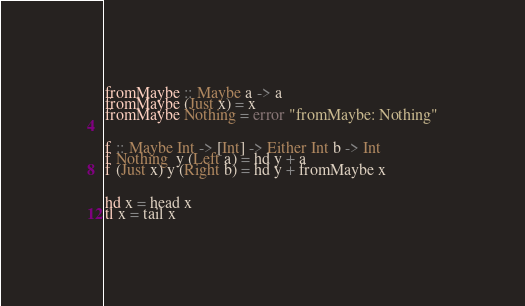Convert code to text. <code><loc_0><loc_0><loc_500><loc_500><_Haskell_>
fromMaybe :: Maybe a -> a
fromMaybe (Just x) = x
fromMaybe Nothing = error "fromMaybe: Nothing"


f :: Maybe Int -> [Int] -> Either Int b -> Int
f Nothing  y (Left a) = hd y + a
f (Just x) y (Right b) = hd y + fromMaybe x


hd x = head x
tl x = tail x


</code> 